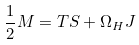Convert formula to latex. <formula><loc_0><loc_0><loc_500><loc_500>\frac { 1 } { 2 } M = T S + \Omega _ { H } J</formula> 